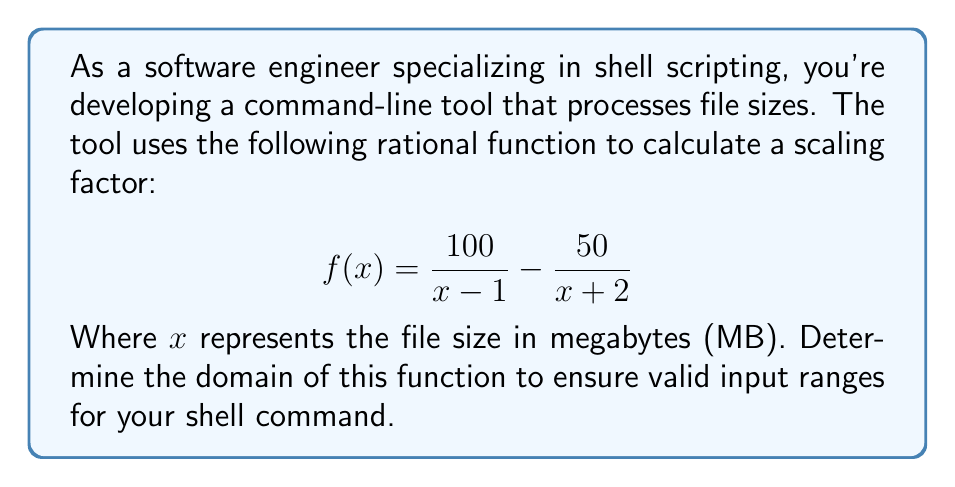Help me with this question. To determine the domain of the rational function, we need to find the values of $x$ for which the function is defined. This means identifying any values that would make the denominators equal to zero.

Step 1: Analyze the first fraction $\frac{100}{x - 1}$
The denominator $x - 1$ would be zero when $x = 1$. So $x$ cannot be 1.

Step 2: Analyze the second fraction $\frac{50}{x + 2}$
The denominator $x + 2$ would be zero when $x = -2$. So $x$ cannot be -2.

Step 3: Combine the restrictions
The function is undefined when $x = 1$ or $x = -2$. Therefore, the domain of the function is all real numbers except these two values.

Step 4: Express the domain in set notation
We can write this as: $x \in \mathbb{R}, x \neq 1, x \neq -2$

Step 5: Consider the context
Since $x$ represents file size in MB, we need to add the practical constraint that $x$ must be positive (file sizes can't be negative or zero).

Therefore, the final domain for this function in the context of file sizes is:
$x \in \mathbb{R}, x > 0, x \neq 1$

This means that in your shell script, you should validate that the input file size is greater than 0 MB and not equal to 1 MB before applying this function.
Answer: $x \in \mathbb{R}, x > 0, x \neq 1$ 